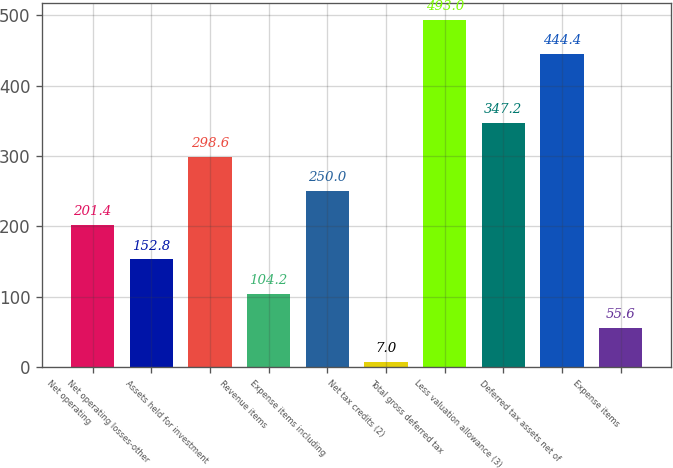Convert chart. <chart><loc_0><loc_0><loc_500><loc_500><bar_chart><fcel>Net operating<fcel>Net operating losses-other<fcel>Assets held for investment<fcel>Revenue items<fcel>Expense items including<fcel>Net tax credits (2)<fcel>Total gross deferred tax<fcel>Less valuation allowance (3)<fcel>Deferred tax assets net of<fcel>Expense items<nl><fcel>201.4<fcel>152.8<fcel>298.6<fcel>104.2<fcel>250<fcel>7<fcel>493<fcel>347.2<fcel>444.4<fcel>55.6<nl></chart> 